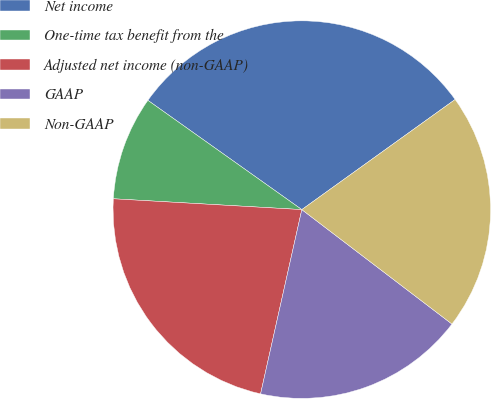Convert chart to OTSL. <chart><loc_0><loc_0><loc_500><loc_500><pie_chart><fcel>Net income<fcel>One-time tax benefit from the<fcel>Adjusted net income (non-GAAP)<fcel>GAAP<fcel>Non-GAAP<nl><fcel>30.26%<fcel>8.91%<fcel>22.41%<fcel>18.14%<fcel>20.28%<nl></chart> 